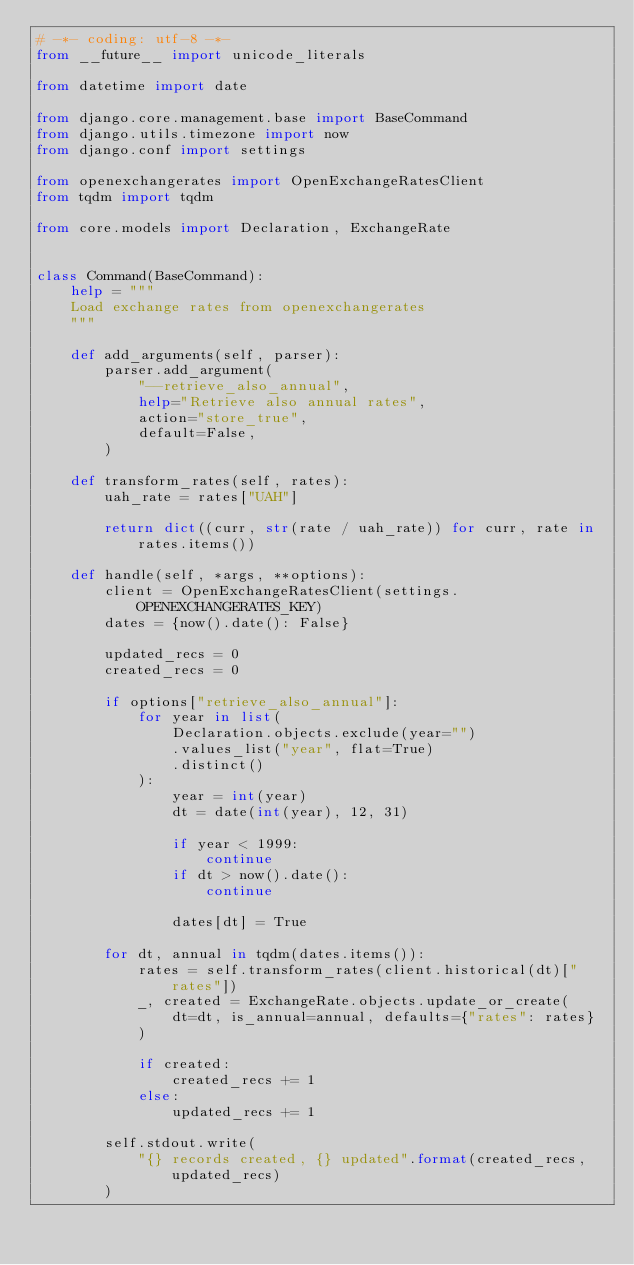<code> <loc_0><loc_0><loc_500><loc_500><_Python_># -*- coding: utf-8 -*-
from __future__ import unicode_literals

from datetime import date

from django.core.management.base import BaseCommand
from django.utils.timezone import now
from django.conf import settings

from openexchangerates import OpenExchangeRatesClient
from tqdm import tqdm

from core.models import Declaration, ExchangeRate


class Command(BaseCommand):
    help = """
    Load exchange rates from openexchangerates
    """

    def add_arguments(self, parser):
        parser.add_argument(
            "--retrieve_also_annual",
            help="Retrieve also annual rates",
            action="store_true",
            default=False,
        )

    def transform_rates(self, rates):
        uah_rate = rates["UAH"]

        return dict((curr, str(rate / uah_rate)) for curr, rate in rates.items())

    def handle(self, *args, **options):
        client = OpenExchangeRatesClient(settings.OPENEXCHANGERATES_KEY)
        dates = {now().date(): False}

        updated_recs = 0
        created_recs = 0

        if options["retrieve_also_annual"]:
            for year in list(
                Declaration.objects.exclude(year="")
                .values_list("year", flat=True)
                .distinct()
            ):
                year = int(year)
                dt = date(int(year), 12, 31)

                if year < 1999:
                    continue
                if dt > now().date():
                    continue

                dates[dt] = True

        for dt, annual in tqdm(dates.items()):
            rates = self.transform_rates(client.historical(dt)["rates"])
            _, created = ExchangeRate.objects.update_or_create(
                dt=dt, is_annual=annual, defaults={"rates": rates}
            )

            if created:
                created_recs += 1
            else:
                updated_recs += 1

        self.stdout.write(
            "{} records created, {} updated".format(created_recs, updated_recs)
        )
</code> 